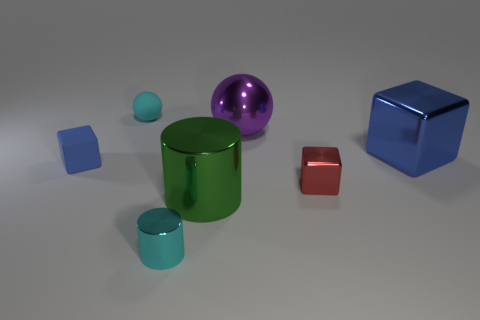Are there any big cyan things made of the same material as the purple sphere?
Offer a very short reply. No. There is a metal thing that is the same color as the small matte ball; what is its shape?
Offer a very short reply. Cylinder. How many small brown rubber objects are there?
Offer a terse response. 0. What number of cylinders are either tiny red metallic objects or large purple things?
Give a very brief answer. 0. What is the color of the other shiny thing that is the same size as the cyan metallic thing?
Your answer should be compact. Red. How many large metal things are both in front of the small red object and behind the big blue shiny block?
Your answer should be compact. 0. What is the large cylinder made of?
Provide a short and direct response. Metal. How many objects are either purple cylinders or red metallic objects?
Your answer should be very brief. 1. There is a blue block on the left side of the large cylinder; does it have the same size as the blue object on the right side of the red metallic block?
Keep it short and to the point. No. How many other objects are the same size as the red shiny object?
Your response must be concise. 3. 